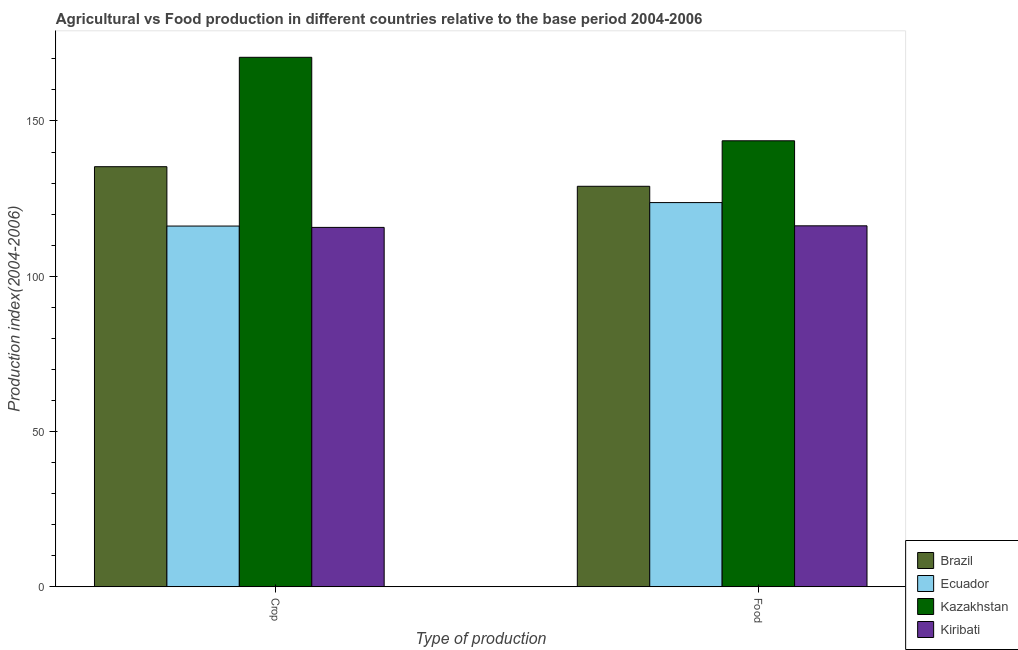How many groups of bars are there?
Offer a very short reply. 2. Are the number of bars on each tick of the X-axis equal?
Provide a short and direct response. Yes. How many bars are there on the 1st tick from the left?
Ensure brevity in your answer.  4. How many bars are there on the 1st tick from the right?
Offer a terse response. 4. What is the label of the 2nd group of bars from the left?
Provide a short and direct response. Food. What is the crop production index in Kazakhstan?
Offer a terse response. 170.51. Across all countries, what is the maximum food production index?
Offer a very short reply. 143.62. Across all countries, what is the minimum crop production index?
Make the answer very short. 115.73. In which country was the crop production index maximum?
Your answer should be very brief. Kazakhstan. In which country was the crop production index minimum?
Your answer should be very brief. Kiribati. What is the total crop production index in the graph?
Your answer should be compact. 537.68. What is the difference between the crop production index in Brazil and that in Ecuador?
Keep it short and to the point. 19.12. What is the difference between the crop production index in Kazakhstan and the food production index in Brazil?
Your answer should be compact. 41.54. What is the average food production index per country?
Give a very brief answer. 128.14. What is the difference between the crop production index and food production index in Ecuador?
Give a very brief answer. -7.56. In how many countries, is the food production index greater than 50 ?
Give a very brief answer. 4. What is the ratio of the crop production index in Kiribati to that in Kazakhstan?
Provide a short and direct response. 0.68. Is the crop production index in Kazakhstan less than that in Brazil?
Provide a short and direct response. No. What does the 2nd bar from the left in Food represents?
Offer a very short reply. Ecuador. What does the 2nd bar from the right in Food represents?
Offer a very short reply. Kazakhstan. Are the values on the major ticks of Y-axis written in scientific E-notation?
Your answer should be compact. No. Does the graph contain any zero values?
Your response must be concise. No. How many legend labels are there?
Your answer should be compact. 4. How are the legend labels stacked?
Make the answer very short. Vertical. What is the title of the graph?
Offer a very short reply. Agricultural vs Food production in different countries relative to the base period 2004-2006. Does "Guatemala" appear as one of the legend labels in the graph?
Your answer should be very brief. No. What is the label or title of the X-axis?
Offer a terse response. Type of production. What is the label or title of the Y-axis?
Your response must be concise. Production index(2004-2006). What is the Production index(2004-2006) in Brazil in Crop?
Give a very brief answer. 135.28. What is the Production index(2004-2006) in Ecuador in Crop?
Make the answer very short. 116.16. What is the Production index(2004-2006) of Kazakhstan in Crop?
Make the answer very short. 170.51. What is the Production index(2004-2006) in Kiribati in Crop?
Offer a terse response. 115.73. What is the Production index(2004-2006) in Brazil in Food?
Your response must be concise. 128.97. What is the Production index(2004-2006) in Ecuador in Food?
Give a very brief answer. 123.72. What is the Production index(2004-2006) of Kazakhstan in Food?
Give a very brief answer. 143.62. What is the Production index(2004-2006) of Kiribati in Food?
Provide a short and direct response. 116.24. Across all Type of production, what is the maximum Production index(2004-2006) of Brazil?
Make the answer very short. 135.28. Across all Type of production, what is the maximum Production index(2004-2006) in Ecuador?
Your answer should be very brief. 123.72. Across all Type of production, what is the maximum Production index(2004-2006) of Kazakhstan?
Offer a terse response. 170.51. Across all Type of production, what is the maximum Production index(2004-2006) of Kiribati?
Your answer should be very brief. 116.24. Across all Type of production, what is the minimum Production index(2004-2006) of Brazil?
Your response must be concise. 128.97. Across all Type of production, what is the minimum Production index(2004-2006) of Ecuador?
Your answer should be compact. 116.16. Across all Type of production, what is the minimum Production index(2004-2006) in Kazakhstan?
Give a very brief answer. 143.62. Across all Type of production, what is the minimum Production index(2004-2006) of Kiribati?
Offer a very short reply. 115.73. What is the total Production index(2004-2006) of Brazil in the graph?
Your answer should be very brief. 264.25. What is the total Production index(2004-2006) of Ecuador in the graph?
Your answer should be compact. 239.88. What is the total Production index(2004-2006) of Kazakhstan in the graph?
Make the answer very short. 314.13. What is the total Production index(2004-2006) of Kiribati in the graph?
Your response must be concise. 231.97. What is the difference between the Production index(2004-2006) of Brazil in Crop and that in Food?
Offer a very short reply. 6.31. What is the difference between the Production index(2004-2006) in Ecuador in Crop and that in Food?
Make the answer very short. -7.56. What is the difference between the Production index(2004-2006) of Kazakhstan in Crop and that in Food?
Provide a succinct answer. 26.89. What is the difference between the Production index(2004-2006) of Kiribati in Crop and that in Food?
Provide a succinct answer. -0.51. What is the difference between the Production index(2004-2006) of Brazil in Crop and the Production index(2004-2006) of Ecuador in Food?
Provide a short and direct response. 11.56. What is the difference between the Production index(2004-2006) of Brazil in Crop and the Production index(2004-2006) of Kazakhstan in Food?
Provide a short and direct response. -8.34. What is the difference between the Production index(2004-2006) in Brazil in Crop and the Production index(2004-2006) in Kiribati in Food?
Offer a very short reply. 19.04. What is the difference between the Production index(2004-2006) of Ecuador in Crop and the Production index(2004-2006) of Kazakhstan in Food?
Provide a short and direct response. -27.46. What is the difference between the Production index(2004-2006) of Ecuador in Crop and the Production index(2004-2006) of Kiribati in Food?
Provide a succinct answer. -0.08. What is the difference between the Production index(2004-2006) in Kazakhstan in Crop and the Production index(2004-2006) in Kiribati in Food?
Your answer should be compact. 54.27. What is the average Production index(2004-2006) of Brazil per Type of production?
Make the answer very short. 132.12. What is the average Production index(2004-2006) in Ecuador per Type of production?
Keep it short and to the point. 119.94. What is the average Production index(2004-2006) of Kazakhstan per Type of production?
Your answer should be very brief. 157.06. What is the average Production index(2004-2006) of Kiribati per Type of production?
Your answer should be very brief. 115.98. What is the difference between the Production index(2004-2006) in Brazil and Production index(2004-2006) in Ecuador in Crop?
Provide a succinct answer. 19.12. What is the difference between the Production index(2004-2006) of Brazil and Production index(2004-2006) of Kazakhstan in Crop?
Give a very brief answer. -35.23. What is the difference between the Production index(2004-2006) of Brazil and Production index(2004-2006) of Kiribati in Crop?
Provide a short and direct response. 19.55. What is the difference between the Production index(2004-2006) of Ecuador and Production index(2004-2006) of Kazakhstan in Crop?
Provide a short and direct response. -54.35. What is the difference between the Production index(2004-2006) in Ecuador and Production index(2004-2006) in Kiribati in Crop?
Keep it short and to the point. 0.43. What is the difference between the Production index(2004-2006) in Kazakhstan and Production index(2004-2006) in Kiribati in Crop?
Offer a terse response. 54.78. What is the difference between the Production index(2004-2006) in Brazil and Production index(2004-2006) in Ecuador in Food?
Give a very brief answer. 5.25. What is the difference between the Production index(2004-2006) in Brazil and Production index(2004-2006) in Kazakhstan in Food?
Give a very brief answer. -14.65. What is the difference between the Production index(2004-2006) in Brazil and Production index(2004-2006) in Kiribati in Food?
Your response must be concise. 12.73. What is the difference between the Production index(2004-2006) of Ecuador and Production index(2004-2006) of Kazakhstan in Food?
Offer a very short reply. -19.9. What is the difference between the Production index(2004-2006) of Ecuador and Production index(2004-2006) of Kiribati in Food?
Provide a succinct answer. 7.48. What is the difference between the Production index(2004-2006) in Kazakhstan and Production index(2004-2006) in Kiribati in Food?
Make the answer very short. 27.38. What is the ratio of the Production index(2004-2006) of Brazil in Crop to that in Food?
Provide a succinct answer. 1.05. What is the ratio of the Production index(2004-2006) of Ecuador in Crop to that in Food?
Give a very brief answer. 0.94. What is the ratio of the Production index(2004-2006) of Kazakhstan in Crop to that in Food?
Offer a very short reply. 1.19. What is the difference between the highest and the second highest Production index(2004-2006) of Brazil?
Ensure brevity in your answer.  6.31. What is the difference between the highest and the second highest Production index(2004-2006) of Ecuador?
Offer a very short reply. 7.56. What is the difference between the highest and the second highest Production index(2004-2006) of Kazakhstan?
Provide a short and direct response. 26.89. What is the difference between the highest and the second highest Production index(2004-2006) in Kiribati?
Your answer should be compact. 0.51. What is the difference between the highest and the lowest Production index(2004-2006) in Brazil?
Provide a short and direct response. 6.31. What is the difference between the highest and the lowest Production index(2004-2006) in Ecuador?
Keep it short and to the point. 7.56. What is the difference between the highest and the lowest Production index(2004-2006) in Kazakhstan?
Offer a very short reply. 26.89. What is the difference between the highest and the lowest Production index(2004-2006) of Kiribati?
Provide a short and direct response. 0.51. 